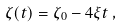<formula> <loc_0><loc_0><loc_500><loc_500>\zeta ( t ) = \zeta _ { 0 } - 4 \xi t \, ,</formula> 